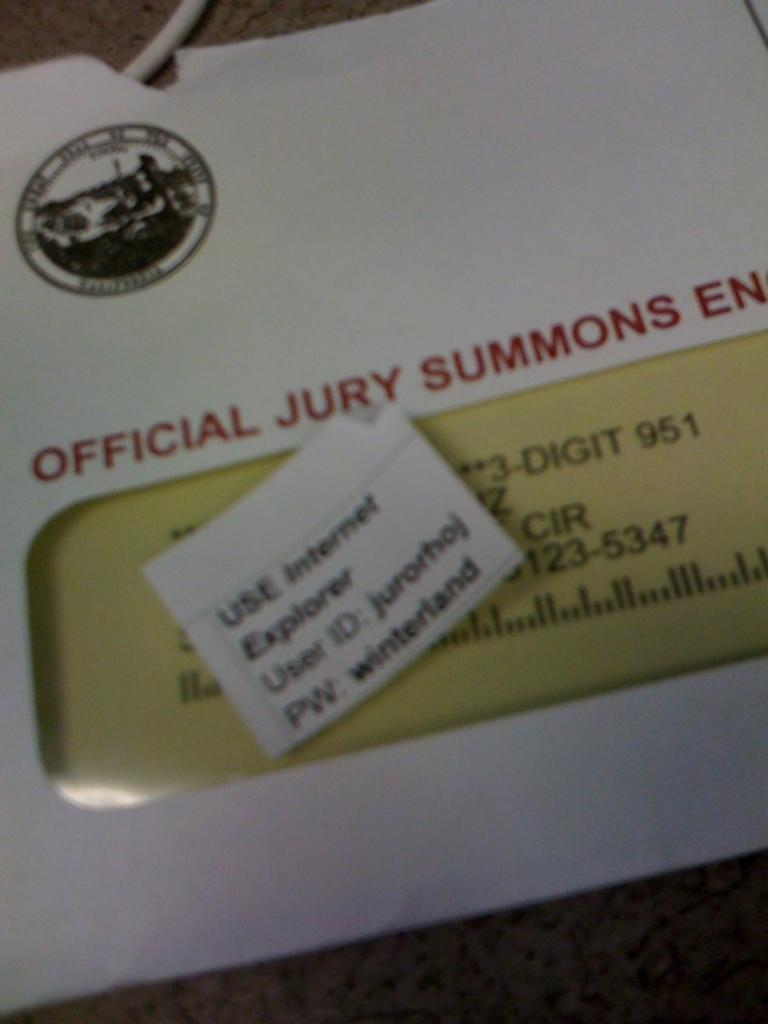What is located in the foreground of the image? There is a white envelope in the foreground of the image. Can you describe what is written on the envelope? Unfortunately, the specific content of what is written on the envelope cannot be determined from the image. What might the envelope be used for? The envelope could be used for sending a letter or document, but the purpose cannot be definitively determined from the image. Is the envelope currently on fire in the image? No, there is no indication that the envelope is on fire in the image. 